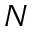Convert formula to latex. <formula><loc_0><loc_0><loc_500><loc_500>N</formula> 